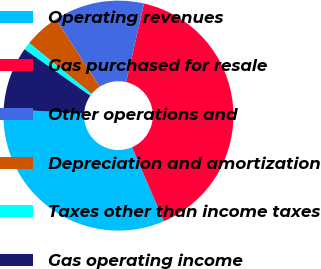<chart> <loc_0><loc_0><loc_500><loc_500><pie_chart><fcel>Operating revenues<fcel>Gas purchased for resale<fcel>Other operations and<fcel>Depreciation and amortization<fcel>Taxes other than income taxes<fcel>Gas operating income<nl><fcel>32.4%<fcel>39.96%<fcel>12.74%<fcel>4.97%<fcel>1.08%<fcel>8.86%<nl></chart> 